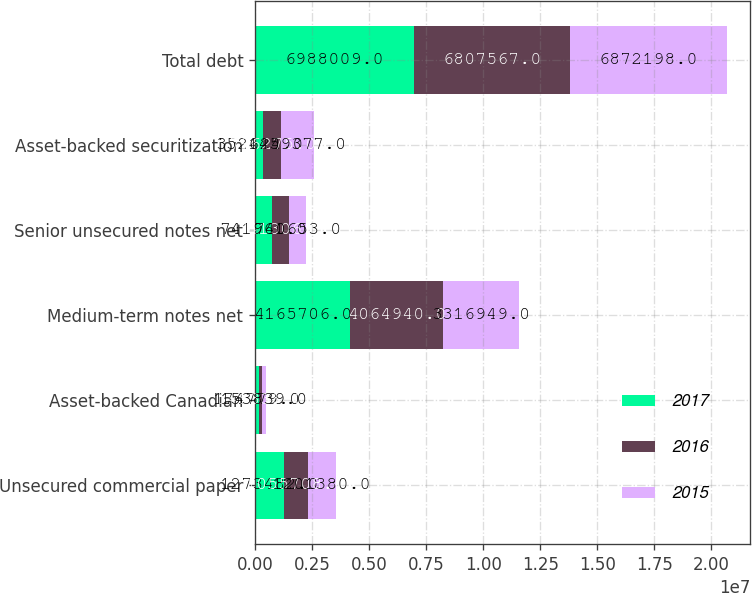Convert chart. <chart><loc_0><loc_0><loc_500><loc_500><stacked_bar_chart><ecel><fcel>Unsecured commercial paper<fcel>Asset-backed Canadian<fcel>Medium-term notes net<fcel>Senior unsecured notes net<fcel>Asset-backed securitization<fcel>Total debt<nl><fcel>2017<fcel>1.27348e+06<fcel>174779<fcel>4.16571e+06<fcel>741961<fcel>352624<fcel>6.98801e+06<nl><fcel>2016<fcel>1.05571e+06<fcel>149338<fcel>4.06494e+06<fcel>741306<fcel>796275<fcel>6.80757e+06<nl><fcel>2015<fcel>1.20138e+06<fcel>153839<fcel>3.31695e+06<fcel>740653<fcel>1.45938e+06<fcel>6.8722e+06<nl></chart> 